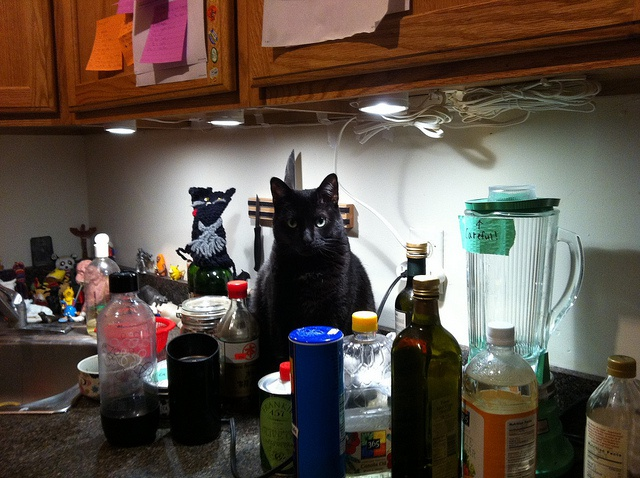Describe the objects in this image and their specific colors. I can see cat in maroon, black, gray, and darkgray tones, bottle in maroon, black, darkgreen, and gray tones, bottle in maroon, olive, gray, and black tones, bottle in maroon, black, brown, gray, and darkgray tones, and bottle in maroon, black, gray, white, and darkgray tones in this image. 